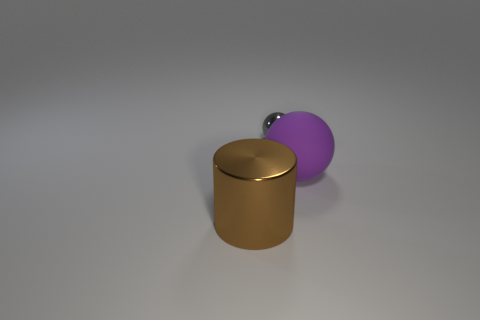Could you tell me the possible use of the brown object? From this image, the brown object might be a container or a canister due to its cylindrical shape and lid. It could be used for storing small items, such as tea, coffee, or spices. What about the purple sphere? What could it be used for? The purple sphere might serve various purposes, such as a decorative object. Given its rubber-like material, it could also be a stress ball, used for hand exercises or as a playful item. 